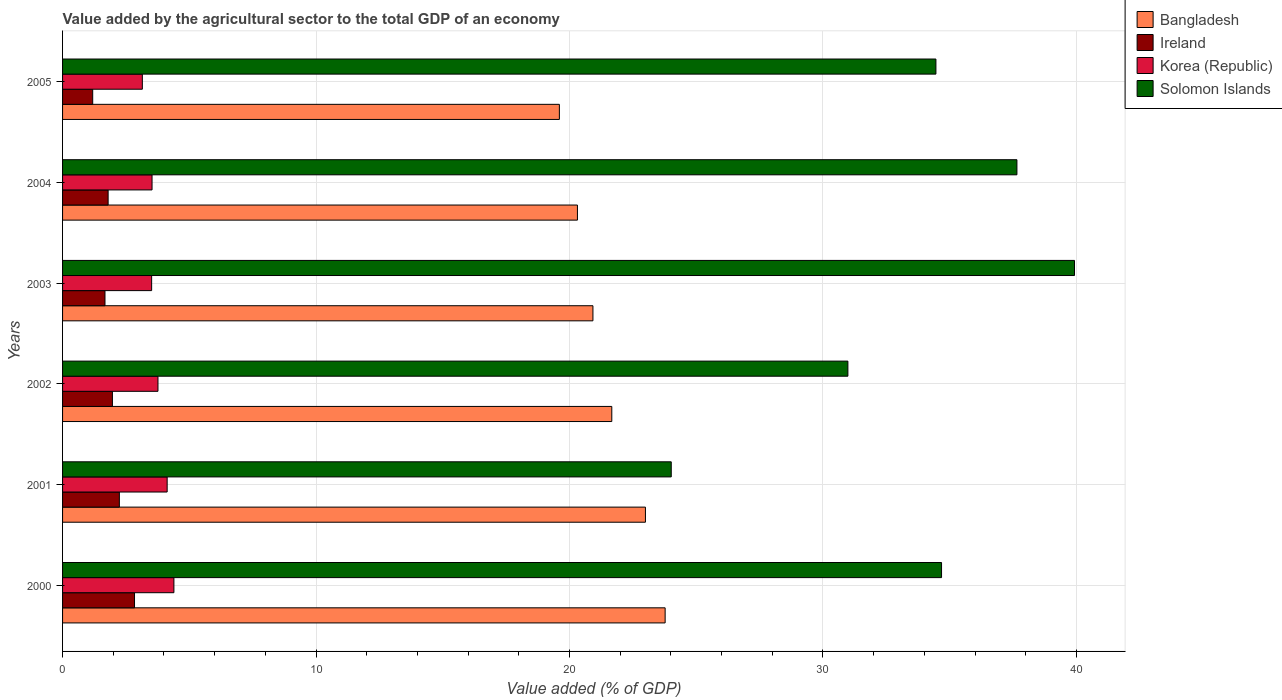How many different coloured bars are there?
Offer a very short reply. 4. Are the number of bars per tick equal to the number of legend labels?
Your answer should be very brief. Yes. How many bars are there on the 5th tick from the bottom?
Ensure brevity in your answer.  4. What is the label of the 3rd group of bars from the top?
Your answer should be compact. 2003. In how many cases, is the number of bars for a given year not equal to the number of legend labels?
Your answer should be very brief. 0. What is the value added by the agricultural sector to the total GDP in Solomon Islands in 2005?
Provide a succinct answer. 34.46. Across all years, what is the maximum value added by the agricultural sector to the total GDP in Korea (Republic)?
Offer a terse response. 4.39. Across all years, what is the minimum value added by the agricultural sector to the total GDP in Bangladesh?
Provide a succinct answer. 19.6. In which year was the value added by the agricultural sector to the total GDP in Solomon Islands minimum?
Keep it short and to the point. 2001. What is the total value added by the agricultural sector to the total GDP in Ireland in the graph?
Provide a succinct answer. 11.71. What is the difference between the value added by the agricultural sector to the total GDP in Korea (Republic) in 2000 and that in 2003?
Make the answer very short. 0.88. What is the difference between the value added by the agricultural sector to the total GDP in Solomon Islands in 2004 and the value added by the agricultural sector to the total GDP in Bangladesh in 2002?
Keep it short and to the point. 15.98. What is the average value added by the agricultural sector to the total GDP in Bangladesh per year?
Offer a terse response. 21.55. In the year 2003, what is the difference between the value added by the agricultural sector to the total GDP in Korea (Republic) and value added by the agricultural sector to the total GDP in Bangladesh?
Give a very brief answer. -17.41. What is the ratio of the value added by the agricultural sector to the total GDP in Korea (Republic) in 2000 to that in 2001?
Offer a very short reply. 1.06. Is the difference between the value added by the agricultural sector to the total GDP in Korea (Republic) in 2000 and 2004 greater than the difference between the value added by the agricultural sector to the total GDP in Bangladesh in 2000 and 2004?
Your answer should be compact. No. What is the difference between the highest and the second highest value added by the agricultural sector to the total GDP in Korea (Republic)?
Give a very brief answer. 0.27. What is the difference between the highest and the lowest value added by the agricultural sector to the total GDP in Ireland?
Provide a succinct answer. 1.65. In how many years, is the value added by the agricultural sector to the total GDP in Solomon Islands greater than the average value added by the agricultural sector to the total GDP in Solomon Islands taken over all years?
Ensure brevity in your answer.  4. Is the sum of the value added by the agricultural sector to the total GDP in Solomon Islands in 2000 and 2005 greater than the maximum value added by the agricultural sector to the total GDP in Korea (Republic) across all years?
Keep it short and to the point. Yes. Is it the case that in every year, the sum of the value added by the agricultural sector to the total GDP in Korea (Republic) and value added by the agricultural sector to the total GDP in Solomon Islands is greater than the sum of value added by the agricultural sector to the total GDP in Ireland and value added by the agricultural sector to the total GDP in Bangladesh?
Offer a very short reply. No. What does the 2nd bar from the bottom in 2001 represents?
Your answer should be very brief. Ireland. How many bars are there?
Offer a terse response. 24. What is the difference between two consecutive major ticks on the X-axis?
Your response must be concise. 10. Does the graph contain any zero values?
Your answer should be very brief. No. Does the graph contain grids?
Offer a very short reply. Yes. How many legend labels are there?
Offer a terse response. 4. What is the title of the graph?
Offer a terse response. Value added by the agricultural sector to the total GDP of an economy. What is the label or title of the X-axis?
Make the answer very short. Value added (% of GDP). What is the Value added (% of GDP) of Bangladesh in 2000?
Make the answer very short. 23.77. What is the Value added (% of GDP) of Ireland in 2000?
Your response must be concise. 2.84. What is the Value added (% of GDP) in Korea (Republic) in 2000?
Make the answer very short. 4.39. What is the Value added (% of GDP) of Solomon Islands in 2000?
Your response must be concise. 34.68. What is the Value added (% of GDP) in Bangladesh in 2001?
Your response must be concise. 23. What is the Value added (% of GDP) in Ireland in 2001?
Your answer should be compact. 2.24. What is the Value added (% of GDP) in Korea (Republic) in 2001?
Give a very brief answer. 4.13. What is the Value added (% of GDP) in Solomon Islands in 2001?
Offer a terse response. 24.01. What is the Value added (% of GDP) in Bangladesh in 2002?
Provide a short and direct response. 21.67. What is the Value added (% of GDP) in Ireland in 2002?
Offer a terse response. 1.97. What is the Value added (% of GDP) in Korea (Republic) in 2002?
Keep it short and to the point. 3.76. What is the Value added (% of GDP) in Solomon Islands in 2002?
Make the answer very short. 30.98. What is the Value added (% of GDP) in Bangladesh in 2003?
Provide a short and direct response. 20.92. What is the Value added (% of GDP) in Ireland in 2003?
Offer a terse response. 1.67. What is the Value added (% of GDP) of Korea (Republic) in 2003?
Ensure brevity in your answer.  3.51. What is the Value added (% of GDP) in Solomon Islands in 2003?
Your answer should be compact. 39.92. What is the Value added (% of GDP) of Bangladesh in 2004?
Provide a succinct answer. 20.31. What is the Value added (% of GDP) in Ireland in 2004?
Your answer should be compact. 1.8. What is the Value added (% of GDP) of Korea (Republic) in 2004?
Keep it short and to the point. 3.53. What is the Value added (% of GDP) of Solomon Islands in 2004?
Make the answer very short. 37.65. What is the Value added (% of GDP) of Bangladesh in 2005?
Provide a succinct answer. 19.6. What is the Value added (% of GDP) in Ireland in 2005?
Make the answer very short. 1.19. What is the Value added (% of GDP) of Korea (Republic) in 2005?
Ensure brevity in your answer.  3.15. What is the Value added (% of GDP) in Solomon Islands in 2005?
Your answer should be very brief. 34.46. Across all years, what is the maximum Value added (% of GDP) of Bangladesh?
Ensure brevity in your answer.  23.77. Across all years, what is the maximum Value added (% of GDP) of Ireland?
Your response must be concise. 2.84. Across all years, what is the maximum Value added (% of GDP) of Korea (Republic)?
Make the answer very short. 4.39. Across all years, what is the maximum Value added (% of GDP) in Solomon Islands?
Provide a short and direct response. 39.92. Across all years, what is the minimum Value added (% of GDP) in Bangladesh?
Give a very brief answer. 19.6. Across all years, what is the minimum Value added (% of GDP) in Ireland?
Offer a very short reply. 1.19. Across all years, what is the minimum Value added (% of GDP) of Korea (Republic)?
Offer a terse response. 3.15. Across all years, what is the minimum Value added (% of GDP) of Solomon Islands?
Your answer should be compact. 24.01. What is the total Value added (% of GDP) of Bangladesh in the graph?
Make the answer very short. 129.27. What is the total Value added (% of GDP) in Ireland in the graph?
Offer a very short reply. 11.71. What is the total Value added (% of GDP) in Korea (Republic) in the graph?
Keep it short and to the point. 22.47. What is the total Value added (% of GDP) in Solomon Islands in the graph?
Offer a very short reply. 201.7. What is the difference between the Value added (% of GDP) of Bangladesh in 2000 and that in 2001?
Ensure brevity in your answer.  0.78. What is the difference between the Value added (% of GDP) in Ireland in 2000 and that in 2001?
Give a very brief answer. 0.6. What is the difference between the Value added (% of GDP) in Korea (Republic) in 2000 and that in 2001?
Ensure brevity in your answer.  0.27. What is the difference between the Value added (% of GDP) of Solomon Islands in 2000 and that in 2001?
Offer a very short reply. 10.66. What is the difference between the Value added (% of GDP) of Bangladesh in 2000 and that in 2002?
Your answer should be compact. 2.1. What is the difference between the Value added (% of GDP) in Ireland in 2000 and that in 2002?
Provide a succinct answer. 0.87. What is the difference between the Value added (% of GDP) in Korea (Republic) in 2000 and that in 2002?
Your answer should be very brief. 0.63. What is the difference between the Value added (% of GDP) of Solomon Islands in 2000 and that in 2002?
Your response must be concise. 3.7. What is the difference between the Value added (% of GDP) in Bangladesh in 2000 and that in 2003?
Provide a short and direct response. 2.85. What is the difference between the Value added (% of GDP) in Ireland in 2000 and that in 2003?
Your answer should be compact. 1.17. What is the difference between the Value added (% of GDP) of Korea (Republic) in 2000 and that in 2003?
Offer a very short reply. 0.88. What is the difference between the Value added (% of GDP) of Solomon Islands in 2000 and that in 2003?
Provide a short and direct response. -5.25. What is the difference between the Value added (% of GDP) in Bangladesh in 2000 and that in 2004?
Make the answer very short. 3.46. What is the difference between the Value added (% of GDP) of Ireland in 2000 and that in 2004?
Ensure brevity in your answer.  1.04. What is the difference between the Value added (% of GDP) in Korea (Republic) in 2000 and that in 2004?
Ensure brevity in your answer.  0.86. What is the difference between the Value added (% of GDP) in Solomon Islands in 2000 and that in 2004?
Your response must be concise. -2.97. What is the difference between the Value added (% of GDP) in Bangladesh in 2000 and that in 2005?
Your answer should be very brief. 4.17. What is the difference between the Value added (% of GDP) of Ireland in 2000 and that in 2005?
Ensure brevity in your answer.  1.65. What is the difference between the Value added (% of GDP) in Korea (Republic) in 2000 and that in 2005?
Keep it short and to the point. 1.25. What is the difference between the Value added (% of GDP) in Solomon Islands in 2000 and that in 2005?
Make the answer very short. 0.22. What is the difference between the Value added (% of GDP) of Bangladesh in 2001 and that in 2002?
Your answer should be compact. 1.33. What is the difference between the Value added (% of GDP) of Ireland in 2001 and that in 2002?
Give a very brief answer. 0.27. What is the difference between the Value added (% of GDP) of Korea (Republic) in 2001 and that in 2002?
Your response must be concise. 0.36. What is the difference between the Value added (% of GDP) in Solomon Islands in 2001 and that in 2002?
Make the answer very short. -6.97. What is the difference between the Value added (% of GDP) of Bangladesh in 2001 and that in 2003?
Keep it short and to the point. 2.07. What is the difference between the Value added (% of GDP) of Ireland in 2001 and that in 2003?
Your answer should be very brief. 0.57. What is the difference between the Value added (% of GDP) in Korea (Republic) in 2001 and that in 2003?
Your answer should be very brief. 0.61. What is the difference between the Value added (% of GDP) of Solomon Islands in 2001 and that in 2003?
Keep it short and to the point. -15.91. What is the difference between the Value added (% of GDP) in Bangladesh in 2001 and that in 2004?
Ensure brevity in your answer.  2.68. What is the difference between the Value added (% of GDP) in Ireland in 2001 and that in 2004?
Your response must be concise. 0.44. What is the difference between the Value added (% of GDP) in Korea (Republic) in 2001 and that in 2004?
Your answer should be compact. 0.6. What is the difference between the Value added (% of GDP) in Solomon Islands in 2001 and that in 2004?
Give a very brief answer. -13.64. What is the difference between the Value added (% of GDP) in Bangladesh in 2001 and that in 2005?
Offer a very short reply. 3.4. What is the difference between the Value added (% of GDP) in Ireland in 2001 and that in 2005?
Provide a short and direct response. 1.05. What is the difference between the Value added (% of GDP) in Korea (Republic) in 2001 and that in 2005?
Keep it short and to the point. 0.98. What is the difference between the Value added (% of GDP) in Solomon Islands in 2001 and that in 2005?
Make the answer very short. -10.44. What is the difference between the Value added (% of GDP) of Bangladesh in 2002 and that in 2003?
Make the answer very short. 0.74. What is the difference between the Value added (% of GDP) of Ireland in 2002 and that in 2003?
Your answer should be very brief. 0.29. What is the difference between the Value added (% of GDP) in Korea (Republic) in 2002 and that in 2003?
Your response must be concise. 0.25. What is the difference between the Value added (% of GDP) in Solomon Islands in 2002 and that in 2003?
Offer a terse response. -8.94. What is the difference between the Value added (% of GDP) in Bangladesh in 2002 and that in 2004?
Provide a short and direct response. 1.36. What is the difference between the Value added (% of GDP) in Ireland in 2002 and that in 2004?
Your response must be concise. 0.17. What is the difference between the Value added (% of GDP) in Korea (Republic) in 2002 and that in 2004?
Give a very brief answer. 0.23. What is the difference between the Value added (% of GDP) of Solomon Islands in 2002 and that in 2004?
Provide a succinct answer. -6.67. What is the difference between the Value added (% of GDP) in Bangladesh in 2002 and that in 2005?
Your answer should be very brief. 2.07. What is the difference between the Value added (% of GDP) of Ireland in 2002 and that in 2005?
Ensure brevity in your answer.  0.78. What is the difference between the Value added (% of GDP) in Korea (Republic) in 2002 and that in 2005?
Provide a short and direct response. 0.62. What is the difference between the Value added (% of GDP) in Solomon Islands in 2002 and that in 2005?
Your answer should be very brief. -3.47. What is the difference between the Value added (% of GDP) in Bangladesh in 2003 and that in 2004?
Your answer should be very brief. 0.61. What is the difference between the Value added (% of GDP) of Ireland in 2003 and that in 2004?
Keep it short and to the point. -0.12. What is the difference between the Value added (% of GDP) of Korea (Republic) in 2003 and that in 2004?
Keep it short and to the point. -0.02. What is the difference between the Value added (% of GDP) in Solomon Islands in 2003 and that in 2004?
Your answer should be compact. 2.27. What is the difference between the Value added (% of GDP) in Bangladesh in 2003 and that in 2005?
Offer a very short reply. 1.32. What is the difference between the Value added (% of GDP) of Ireland in 2003 and that in 2005?
Your answer should be compact. 0.48. What is the difference between the Value added (% of GDP) of Korea (Republic) in 2003 and that in 2005?
Keep it short and to the point. 0.37. What is the difference between the Value added (% of GDP) in Solomon Islands in 2003 and that in 2005?
Provide a short and direct response. 5.47. What is the difference between the Value added (% of GDP) of Bangladesh in 2004 and that in 2005?
Your answer should be compact. 0.71. What is the difference between the Value added (% of GDP) of Ireland in 2004 and that in 2005?
Offer a terse response. 0.61. What is the difference between the Value added (% of GDP) in Korea (Republic) in 2004 and that in 2005?
Keep it short and to the point. 0.38. What is the difference between the Value added (% of GDP) of Solomon Islands in 2004 and that in 2005?
Your answer should be very brief. 3.2. What is the difference between the Value added (% of GDP) in Bangladesh in 2000 and the Value added (% of GDP) in Ireland in 2001?
Offer a very short reply. 21.53. What is the difference between the Value added (% of GDP) in Bangladesh in 2000 and the Value added (% of GDP) in Korea (Republic) in 2001?
Your answer should be compact. 19.65. What is the difference between the Value added (% of GDP) of Bangladesh in 2000 and the Value added (% of GDP) of Solomon Islands in 2001?
Your response must be concise. -0.24. What is the difference between the Value added (% of GDP) of Ireland in 2000 and the Value added (% of GDP) of Korea (Republic) in 2001?
Your response must be concise. -1.29. What is the difference between the Value added (% of GDP) in Ireland in 2000 and the Value added (% of GDP) in Solomon Islands in 2001?
Give a very brief answer. -21.18. What is the difference between the Value added (% of GDP) of Korea (Republic) in 2000 and the Value added (% of GDP) of Solomon Islands in 2001?
Offer a very short reply. -19.62. What is the difference between the Value added (% of GDP) of Bangladesh in 2000 and the Value added (% of GDP) of Ireland in 2002?
Provide a short and direct response. 21.81. What is the difference between the Value added (% of GDP) in Bangladesh in 2000 and the Value added (% of GDP) in Korea (Republic) in 2002?
Offer a very short reply. 20.01. What is the difference between the Value added (% of GDP) of Bangladesh in 2000 and the Value added (% of GDP) of Solomon Islands in 2002?
Make the answer very short. -7.21. What is the difference between the Value added (% of GDP) of Ireland in 2000 and the Value added (% of GDP) of Korea (Republic) in 2002?
Offer a terse response. -0.92. What is the difference between the Value added (% of GDP) in Ireland in 2000 and the Value added (% of GDP) in Solomon Islands in 2002?
Make the answer very short. -28.14. What is the difference between the Value added (% of GDP) in Korea (Republic) in 2000 and the Value added (% of GDP) in Solomon Islands in 2002?
Give a very brief answer. -26.59. What is the difference between the Value added (% of GDP) in Bangladesh in 2000 and the Value added (% of GDP) in Ireland in 2003?
Ensure brevity in your answer.  22.1. What is the difference between the Value added (% of GDP) in Bangladesh in 2000 and the Value added (% of GDP) in Korea (Republic) in 2003?
Offer a terse response. 20.26. What is the difference between the Value added (% of GDP) of Bangladesh in 2000 and the Value added (% of GDP) of Solomon Islands in 2003?
Ensure brevity in your answer.  -16.15. What is the difference between the Value added (% of GDP) of Ireland in 2000 and the Value added (% of GDP) of Korea (Republic) in 2003?
Provide a succinct answer. -0.68. What is the difference between the Value added (% of GDP) of Ireland in 2000 and the Value added (% of GDP) of Solomon Islands in 2003?
Your response must be concise. -37.08. What is the difference between the Value added (% of GDP) of Korea (Republic) in 2000 and the Value added (% of GDP) of Solomon Islands in 2003?
Make the answer very short. -35.53. What is the difference between the Value added (% of GDP) of Bangladesh in 2000 and the Value added (% of GDP) of Ireland in 2004?
Ensure brevity in your answer.  21.98. What is the difference between the Value added (% of GDP) of Bangladesh in 2000 and the Value added (% of GDP) of Korea (Republic) in 2004?
Make the answer very short. 20.24. What is the difference between the Value added (% of GDP) of Bangladesh in 2000 and the Value added (% of GDP) of Solomon Islands in 2004?
Provide a short and direct response. -13.88. What is the difference between the Value added (% of GDP) of Ireland in 2000 and the Value added (% of GDP) of Korea (Republic) in 2004?
Make the answer very short. -0.69. What is the difference between the Value added (% of GDP) in Ireland in 2000 and the Value added (% of GDP) in Solomon Islands in 2004?
Provide a succinct answer. -34.81. What is the difference between the Value added (% of GDP) in Korea (Republic) in 2000 and the Value added (% of GDP) in Solomon Islands in 2004?
Give a very brief answer. -33.26. What is the difference between the Value added (% of GDP) of Bangladesh in 2000 and the Value added (% of GDP) of Ireland in 2005?
Offer a terse response. 22.58. What is the difference between the Value added (% of GDP) of Bangladesh in 2000 and the Value added (% of GDP) of Korea (Republic) in 2005?
Ensure brevity in your answer.  20.63. What is the difference between the Value added (% of GDP) of Bangladesh in 2000 and the Value added (% of GDP) of Solomon Islands in 2005?
Offer a terse response. -10.68. What is the difference between the Value added (% of GDP) of Ireland in 2000 and the Value added (% of GDP) of Korea (Republic) in 2005?
Your answer should be very brief. -0.31. What is the difference between the Value added (% of GDP) of Ireland in 2000 and the Value added (% of GDP) of Solomon Islands in 2005?
Provide a succinct answer. -31.62. What is the difference between the Value added (% of GDP) of Korea (Republic) in 2000 and the Value added (% of GDP) of Solomon Islands in 2005?
Ensure brevity in your answer.  -30.06. What is the difference between the Value added (% of GDP) in Bangladesh in 2001 and the Value added (% of GDP) in Ireland in 2002?
Offer a very short reply. 21.03. What is the difference between the Value added (% of GDP) of Bangladesh in 2001 and the Value added (% of GDP) of Korea (Republic) in 2002?
Offer a very short reply. 19.23. What is the difference between the Value added (% of GDP) of Bangladesh in 2001 and the Value added (% of GDP) of Solomon Islands in 2002?
Ensure brevity in your answer.  -7.99. What is the difference between the Value added (% of GDP) of Ireland in 2001 and the Value added (% of GDP) of Korea (Republic) in 2002?
Give a very brief answer. -1.52. What is the difference between the Value added (% of GDP) of Ireland in 2001 and the Value added (% of GDP) of Solomon Islands in 2002?
Make the answer very short. -28.74. What is the difference between the Value added (% of GDP) in Korea (Republic) in 2001 and the Value added (% of GDP) in Solomon Islands in 2002?
Provide a short and direct response. -26.86. What is the difference between the Value added (% of GDP) in Bangladesh in 2001 and the Value added (% of GDP) in Ireland in 2003?
Ensure brevity in your answer.  21.32. What is the difference between the Value added (% of GDP) of Bangladesh in 2001 and the Value added (% of GDP) of Korea (Republic) in 2003?
Provide a succinct answer. 19.48. What is the difference between the Value added (% of GDP) of Bangladesh in 2001 and the Value added (% of GDP) of Solomon Islands in 2003?
Offer a terse response. -16.93. What is the difference between the Value added (% of GDP) of Ireland in 2001 and the Value added (% of GDP) of Korea (Republic) in 2003?
Offer a very short reply. -1.27. What is the difference between the Value added (% of GDP) in Ireland in 2001 and the Value added (% of GDP) in Solomon Islands in 2003?
Your response must be concise. -37.68. What is the difference between the Value added (% of GDP) in Korea (Republic) in 2001 and the Value added (% of GDP) in Solomon Islands in 2003?
Offer a very short reply. -35.8. What is the difference between the Value added (% of GDP) in Bangladesh in 2001 and the Value added (% of GDP) in Ireland in 2004?
Your response must be concise. 21.2. What is the difference between the Value added (% of GDP) of Bangladesh in 2001 and the Value added (% of GDP) of Korea (Republic) in 2004?
Your answer should be very brief. 19.47. What is the difference between the Value added (% of GDP) of Bangladesh in 2001 and the Value added (% of GDP) of Solomon Islands in 2004?
Your response must be concise. -14.66. What is the difference between the Value added (% of GDP) of Ireland in 2001 and the Value added (% of GDP) of Korea (Republic) in 2004?
Provide a succinct answer. -1.29. What is the difference between the Value added (% of GDP) in Ireland in 2001 and the Value added (% of GDP) in Solomon Islands in 2004?
Your response must be concise. -35.41. What is the difference between the Value added (% of GDP) of Korea (Republic) in 2001 and the Value added (% of GDP) of Solomon Islands in 2004?
Your response must be concise. -33.53. What is the difference between the Value added (% of GDP) in Bangladesh in 2001 and the Value added (% of GDP) in Ireland in 2005?
Give a very brief answer. 21.81. What is the difference between the Value added (% of GDP) of Bangladesh in 2001 and the Value added (% of GDP) of Korea (Republic) in 2005?
Make the answer very short. 19.85. What is the difference between the Value added (% of GDP) in Bangladesh in 2001 and the Value added (% of GDP) in Solomon Islands in 2005?
Keep it short and to the point. -11.46. What is the difference between the Value added (% of GDP) in Ireland in 2001 and the Value added (% of GDP) in Korea (Republic) in 2005?
Provide a short and direct response. -0.91. What is the difference between the Value added (% of GDP) of Ireland in 2001 and the Value added (% of GDP) of Solomon Islands in 2005?
Ensure brevity in your answer.  -32.22. What is the difference between the Value added (% of GDP) of Korea (Republic) in 2001 and the Value added (% of GDP) of Solomon Islands in 2005?
Make the answer very short. -30.33. What is the difference between the Value added (% of GDP) in Bangladesh in 2002 and the Value added (% of GDP) in Ireland in 2003?
Provide a short and direct response. 20. What is the difference between the Value added (% of GDP) in Bangladesh in 2002 and the Value added (% of GDP) in Korea (Republic) in 2003?
Give a very brief answer. 18.15. What is the difference between the Value added (% of GDP) in Bangladesh in 2002 and the Value added (% of GDP) in Solomon Islands in 2003?
Provide a succinct answer. -18.25. What is the difference between the Value added (% of GDP) of Ireland in 2002 and the Value added (% of GDP) of Korea (Republic) in 2003?
Provide a succinct answer. -1.55. What is the difference between the Value added (% of GDP) of Ireland in 2002 and the Value added (% of GDP) of Solomon Islands in 2003?
Make the answer very short. -37.96. What is the difference between the Value added (% of GDP) in Korea (Republic) in 2002 and the Value added (% of GDP) in Solomon Islands in 2003?
Provide a succinct answer. -36.16. What is the difference between the Value added (% of GDP) of Bangladesh in 2002 and the Value added (% of GDP) of Ireland in 2004?
Your response must be concise. 19.87. What is the difference between the Value added (% of GDP) in Bangladesh in 2002 and the Value added (% of GDP) in Korea (Republic) in 2004?
Make the answer very short. 18.14. What is the difference between the Value added (% of GDP) in Bangladesh in 2002 and the Value added (% of GDP) in Solomon Islands in 2004?
Provide a succinct answer. -15.98. What is the difference between the Value added (% of GDP) of Ireland in 2002 and the Value added (% of GDP) of Korea (Republic) in 2004?
Ensure brevity in your answer.  -1.56. What is the difference between the Value added (% of GDP) in Ireland in 2002 and the Value added (% of GDP) in Solomon Islands in 2004?
Give a very brief answer. -35.68. What is the difference between the Value added (% of GDP) of Korea (Republic) in 2002 and the Value added (% of GDP) of Solomon Islands in 2004?
Your answer should be very brief. -33.89. What is the difference between the Value added (% of GDP) of Bangladesh in 2002 and the Value added (% of GDP) of Ireland in 2005?
Provide a succinct answer. 20.48. What is the difference between the Value added (% of GDP) of Bangladesh in 2002 and the Value added (% of GDP) of Korea (Republic) in 2005?
Offer a very short reply. 18.52. What is the difference between the Value added (% of GDP) of Bangladesh in 2002 and the Value added (% of GDP) of Solomon Islands in 2005?
Ensure brevity in your answer.  -12.79. What is the difference between the Value added (% of GDP) of Ireland in 2002 and the Value added (% of GDP) of Korea (Republic) in 2005?
Make the answer very short. -1.18. What is the difference between the Value added (% of GDP) in Ireland in 2002 and the Value added (% of GDP) in Solomon Islands in 2005?
Provide a short and direct response. -32.49. What is the difference between the Value added (% of GDP) of Korea (Republic) in 2002 and the Value added (% of GDP) of Solomon Islands in 2005?
Your response must be concise. -30.69. What is the difference between the Value added (% of GDP) of Bangladesh in 2003 and the Value added (% of GDP) of Ireland in 2004?
Provide a succinct answer. 19.13. What is the difference between the Value added (% of GDP) in Bangladesh in 2003 and the Value added (% of GDP) in Korea (Republic) in 2004?
Your answer should be very brief. 17.39. What is the difference between the Value added (% of GDP) of Bangladesh in 2003 and the Value added (% of GDP) of Solomon Islands in 2004?
Provide a succinct answer. -16.73. What is the difference between the Value added (% of GDP) in Ireland in 2003 and the Value added (% of GDP) in Korea (Republic) in 2004?
Give a very brief answer. -1.86. What is the difference between the Value added (% of GDP) in Ireland in 2003 and the Value added (% of GDP) in Solomon Islands in 2004?
Offer a terse response. -35.98. What is the difference between the Value added (% of GDP) in Korea (Republic) in 2003 and the Value added (% of GDP) in Solomon Islands in 2004?
Offer a terse response. -34.14. What is the difference between the Value added (% of GDP) in Bangladesh in 2003 and the Value added (% of GDP) in Ireland in 2005?
Give a very brief answer. 19.74. What is the difference between the Value added (% of GDP) of Bangladesh in 2003 and the Value added (% of GDP) of Korea (Republic) in 2005?
Your answer should be very brief. 17.78. What is the difference between the Value added (% of GDP) of Bangladesh in 2003 and the Value added (% of GDP) of Solomon Islands in 2005?
Provide a succinct answer. -13.53. What is the difference between the Value added (% of GDP) of Ireland in 2003 and the Value added (% of GDP) of Korea (Republic) in 2005?
Provide a short and direct response. -1.47. What is the difference between the Value added (% of GDP) in Ireland in 2003 and the Value added (% of GDP) in Solomon Islands in 2005?
Offer a very short reply. -32.78. What is the difference between the Value added (% of GDP) in Korea (Republic) in 2003 and the Value added (% of GDP) in Solomon Islands in 2005?
Your response must be concise. -30.94. What is the difference between the Value added (% of GDP) in Bangladesh in 2004 and the Value added (% of GDP) in Ireland in 2005?
Ensure brevity in your answer.  19.12. What is the difference between the Value added (% of GDP) in Bangladesh in 2004 and the Value added (% of GDP) in Korea (Republic) in 2005?
Keep it short and to the point. 17.17. What is the difference between the Value added (% of GDP) in Bangladesh in 2004 and the Value added (% of GDP) in Solomon Islands in 2005?
Offer a terse response. -14.14. What is the difference between the Value added (% of GDP) in Ireland in 2004 and the Value added (% of GDP) in Korea (Republic) in 2005?
Keep it short and to the point. -1.35. What is the difference between the Value added (% of GDP) of Ireland in 2004 and the Value added (% of GDP) of Solomon Islands in 2005?
Your response must be concise. -32.66. What is the difference between the Value added (% of GDP) in Korea (Republic) in 2004 and the Value added (% of GDP) in Solomon Islands in 2005?
Make the answer very short. -30.93. What is the average Value added (% of GDP) of Bangladesh per year?
Offer a very short reply. 21.55. What is the average Value added (% of GDP) in Ireland per year?
Provide a succinct answer. 1.95. What is the average Value added (% of GDP) in Korea (Republic) per year?
Your answer should be very brief. 3.75. What is the average Value added (% of GDP) of Solomon Islands per year?
Your answer should be very brief. 33.62. In the year 2000, what is the difference between the Value added (% of GDP) in Bangladesh and Value added (% of GDP) in Ireland?
Your answer should be compact. 20.93. In the year 2000, what is the difference between the Value added (% of GDP) in Bangladesh and Value added (% of GDP) in Korea (Republic)?
Keep it short and to the point. 19.38. In the year 2000, what is the difference between the Value added (% of GDP) of Bangladesh and Value added (% of GDP) of Solomon Islands?
Give a very brief answer. -10.91. In the year 2000, what is the difference between the Value added (% of GDP) of Ireland and Value added (% of GDP) of Korea (Republic)?
Ensure brevity in your answer.  -1.55. In the year 2000, what is the difference between the Value added (% of GDP) in Ireland and Value added (% of GDP) in Solomon Islands?
Your answer should be compact. -31.84. In the year 2000, what is the difference between the Value added (% of GDP) of Korea (Republic) and Value added (% of GDP) of Solomon Islands?
Provide a succinct answer. -30.28. In the year 2001, what is the difference between the Value added (% of GDP) in Bangladesh and Value added (% of GDP) in Ireland?
Offer a very short reply. 20.75. In the year 2001, what is the difference between the Value added (% of GDP) of Bangladesh and Value added (% of GDP) of Korea (Republic)?
Your answer should be compact. 18.87. In the year 2001, what is the difference between the Value added (% of GDP) of Bangladesh and Value added (% of GDP) of Solomon Islands?
Your response must be concise. -1.02. In the year 2001, what is the difference between the Value added (% of GDP) of Ireland and Value added (% of GDP) of Korea (Republic)?
Your response must be concise. -1.89. In the year 2001, what is the difference between the Value added (% of GDP) in Ireland and Value added (% of GDP) in Solomon Islands?
Provide a short and direct response. -21.77. In the year 2001, what is the difference between the Value added (% of GDP) in Korea (Republic) and Value added (% of GDP) in Solomon Islands?
Your answer should be very brief. -19.89. In the year 2002, what is the difference between the Value added (% of GDP) of Bangladesh and Value added (% of GDP) of Ireland?
Offer a very short reply. 19.7. In the year 2002, what is the difference between the Value added (% of GDP) in Bangladesh and Value added (% of GDP) in Korea (Republic)?
Your answer should be very brief. 17.9. In the year 2002, what is the difference between the Value added (% of GDP) in Bangladesh and Value added (% of GDP) in Solomon Islands?
Provide a short and direct response. -9.31. In the year 2002, what is the difference between the Value added (% of GDP) in Ireland and Value added (% of GDP) in Korea (Republic)?
Offer a terse response. -1.8. In the year 2002, what is the difference between the Value added (% of GDP) of Ireland and Value added (% of GDP) of Solomon Islands?
Your answer should be compact. -29.02. In the year 2002, what is the difference between the Value added (% of GDP) in Korea (Republic) and Value added (% of GDP) in Solomon Islands?
Give a very brief answer. -27.22. In the year 2003, what is the difference between the Value added (% of GDP) of Bangladesh and Value added (% of GDP) of Ireland?
Provide a short and direct response. 19.25. In the year 2003, what is the difference between the Value added (% of GDP) of Bangladesh and Value added (% of GDP) of Korea (Republic)?
Provide a short and direct response. 17.41. In the year 2003, what is the difference between the Value added (% of GDP) in Bangladesh and Value added (% of GDP) in Solomon Islands?
Offer a terse response. -19. In the year 2003, what is the difference between the Value added (% of GDP) of Ireland and Value added (% of GDP) of Korea (Republic)?
Provide a succinct answer. -1.84. In the year 2003, what is the difference between the Value added (% of GDP) of Ireland and Value added (% of GDP) of Solomon Islands?
Provide a short and direct response. -38.25. In the year 2003, what is the difference between the Value added (% of GDP) in Korea (Republic) and Value added (% of GDP) in Solomon Islands?
Your answer should be compact. -36.41. In the year 2004, what is the difference between the Value added (% of GDP) of Bangladesh and Value added (% of GDP) of Ireland?
Offer a very short reply. 18.52. In the year 2004, what is the difference between the Value added (% of GDP) of Bangladesh and Value added (% of GDP) of Korea (Republic)?
Your response must be concise. 16.78. In the year 2004, what is the difference between the Value added (% of GDP) of Bangladesh and Value added (% of GDP) of Solomon Islands?
Offer a terse response. -17.34. In the year 2004, what is the difference between the Value added (% of GDP) in Ireland and Value added (% of GDP) in Korea (Republic)?
Provide a succinct answer. -1.73. In the year 2004, what is the difference between the Value added (% of GDP) in Ireland and Value added (% of GDP) in Solomon Islands?
Ensure brevity in your answer.  -35.85. In the year 2004, what is the difference between the Value added (% of GDP) in Korea (Republic) and Value added (% of GDP) in Solomon Islands?
Keep it short and to the point. -34.12. In the year 2005, what is the difference between the Value added (% of GDP) of Bangladesh and Value added (% of GDP) of Ireland?
Provide a short and direct response. 18.41. In the year 2005, what is the difference between the Value added (% of GDP) in Bangladesh and Value added (% of GDP) in Korea (Republic)?
Your answer should be very brief. 16.45. In the year 2005, what is the difference between the Value added (% of GDP) of Bangladesh and Value added (% of GDP) of Solomon Islands?
Ensure brevity in your answer.  -14.86. In the year 2005, what is the difference between the Value added (% of GDP) of Ireland and Value added (% of GDP) of Korea (Republic)?
Make the answer very short. -1.96. In the year 2005, what is the difference between the Value added (% of GDP) in Ireland and Value added (% of GDP) in Solomon Islands?
Keep it short and to the point. -33.27. In the year 2005, what is the difference between the Value added (% of GDP) in Korea (Republic) and Value added (% of GDP) in Solomon Islands?
Give a very brief answer. -31.31. What is the ratio of the Value added (% of GDP) in Bangladesh in 2000 to that in 2001?
Your response must be concise. 1.03. What is the ratio of the Value added (% of GDP) in Ireland in 2000 to that in 2001?
Keep it short and to the point. 1.27. What is the ratio of the Value added (% of GDP) in Korea (Republic) in 2000 to that in 2001?
Offer a terse response. 1.06. What is the ratio of the Value added (% of GDP) of Solomon Islands in 2000 to that in 2001?
Give a very brief answer. 1.44. What is the ratio of the Value added (% of GDP) of Bangladesh in 2000 to that in 2002?
Your answer should be compact. 1.1. What is the ratio of the Value added (% of GDP) of Ireland in 2000 to that in 2002?
Make the answer very short. 1.44. What is the ratio of the Value added (% of GDP) of Korea (Republic) in 2000 to that in 2002?
Give a very brief answer. 1.17. What is the ratio of the Value added (% of GDP) in Solomon Islands in 2000 to that in 2002?
Give a very brief answer. 1.12. What is the ratio of the Value added (% of GDP) in Bangladesh in 2000 to that in 2003?
Offer a very short reply. 1.14. What is the ratio of the Value added (% of GDP) of Ireland in 2000 to that in 2003?
Ensure brevity in your answer.  1.7. What is the ratio of the Value added (% of GDP) in Korea (Republic) in 2000 to that in 2003?
Offer a very short reply. 1.25. What is the ratio of the Value added (% of GDP) in Solomon Islands in 2000 to that in 2003?
Offer a very short reply. 0.87. What is the ratio of the Value added (% of GDP) in Bangladesh in 2000 to that in 2004?
Provide a succinct answer. 1.17. What is the ratio of the Value added (% of GDP) in Ireland in 2000 to that in 2004?
Give a very brief answer. 1.58. What is the ratio of the Value added (% of GDP) in Korea (Republic) in 2000 to that in 2004?
Give a very brief answer. 1.24. What is the ratio of the Value added (% of GDP) in Solomon Islands in 2000 to that in 2004?
Provide a short and direct response. 0.92. What is the ratio of the Value added (% of GDP) of Bangladesh in 2000 to that in 2005?
Your answer should be compact. 1.21. What is the ratio of the Value added (% of GDP) in Ireland in 2000 to that in 2005?
Offer a terse response. 2.39. What is the ratio of the Value added (% of GDP) in Korea (Republic) in 2000 to that in 2005?
Your answer should be compact. 1.4. What is the ratio of the Value added (% of GDP) in Solomon Islands in 2000 to that in 2005?
Offer a very short reply. 1.01. What is the ratio of the Value added (% of GDP) of Bangladesh in 2001 to that in 2002?
Your answer should be very brief. 1.06. What is the ratio of the Value added (% of GDP) of Ireland in 2001 to that in 2002?
Make the answer very short. 1.14. What is the ratio of the Value added (% of GDP) in Korea (Republic) in 2001 to that in 2002?
Provide a short and direct response. 1.1. What is the ratio of the Value added (% of GDP) of Solomon Islands in 2001 to that in 2002?
Make the answer very short. 0.78. What is the ratio of the Value added (% of GDP) of Bangladesh in 2001 to that in 2003?
Provide a succinct answer. 1.1. What is the ratio of the Value added (% of GDP) in Ireland in 2001 to that in 2003?
Give a very brief answer. 1.34. What is the ratio of the Value added (% of GDP) in Korea (Republic) in 2001 to that in 2003?
Make the answer very short. 1.17. What is the ratio of the Value added (% of GDP) of Solomon Islands in 2001 to that in 2003?
Ensure brevity in your answer.  0.6. What is the ratio of the Value added (% of GDP) in Bangladesh in 2001 to that in 2004?
Ensure brevity in your answer.  1.13. What is the ratio of the Value added (% of GDP) of Ireland in 2001 to that in 2004?
Keep it short and to the point. 1.25. What is the ratio of the Value added (% of GDP) in Korea (Republic) in 2001 to that in 2004?
Make the answer very short. 1.17. What is the ratio of the Value added (% of GDP) of Solomon Islands in 2001 to that in 2004?
Offer a terse response. 0.64. What is the ratio of the Value added (% of GDP) in Bangladesh in 2001 to that in 2005?
Your response must be concise. 1.17. What is the ratio of the Value added (% of GDP) of Ireland in 2001 to that in 2005?
Your answer should be very brief. 1.88. What is the ratio of the Value added (% of GDP) of Korea (Republic) in 2001 to that in 2005?
Make the answer very short. 1.31. What is the ratio of the Value added (% of GDP) of Solomon Islands in 2001 to that in 2005?
Offer a terse response. 0.7. What is the ratio of the Value added (% of GDP) of Bangladesh in 2002 to that in 2003?
Ensure brevity in your answer.  1.04. What is the ratio of the Value added (% of GDP) in Ireland in 2002 to that in 2003?
Your answer should be very brief. 1.18. What is the ratio of the Value added (% of GDP) in Korea (Republic) in 2002 to that in 2003?
Ensure brevity in your answer.  1.07. What is the ratio of the Value added (% of GDP) in Solomon Islands in 2002 to that in 2003?
Provide a short and direct response. 0.78. What is the ratio of the Value added (% of GDP) of Bangladesh in 2002 to that in 2004?
Your response must be concise. 1.07. What is the ratio of the Value added (% of GDP) in Ireland in 2002 to that in 2004?
Ensure brevity in your answer.  1.09. What is the ratio of the Value added (% of GDP) of Korea (Republic) in 2002 to that in 2004?
Offer a terse response. 1.07. What is the ratio of the Value added (% of GDP) of Solomon Islands in 2002 to that in 2004?
Keep it short and to the point. 0.82. What is the ratio of the Value added (% of GDP) in Bangladesh in 2002 to that in 2005?
Give a very brief answer. 1.11. What is the ratio of the Value added (% of GDP) in Ireland in 2002 to that in 2005?
Your answer should be compact. 1.65. What is the ratio of the Value added (% of GDP) of Korea (Republic) in 2002 to that in 2005?
Provide a short and direct response. 1.2. What is the ratio of the Value added (% of GDP) in Solomon Islands in 2002 to that in 2005?
Your answer should be very brief. 0.9. What is the ratio of the Value added (% of GDP) in Bangladesh in 2003 to that in 2004?
Ensure brevity in your answer.  1.03. What is the ratio of the Value added (% of GDP) of Solomon Islands in 2003 to that in 2004?
Provide a succinct answer. 1.06. What is the ratio of the Value added (% of GDP) of Bangladesh in 2003 to that in 2005?
Provide a succinct answer. 1.07. What is the ratio of the Value added (% of GDP) of Ireland in 2003 to that in 2005?
Ensure brevity in your answer.  1.41. What is the ratio of the Value added (% of GDP) of Korea (Republic) in 2003 to that in 2005?
Provide a short and direct response. 1.12. What is the ratio of the Value added (% of GDP) of Solomon Islands in 2003 to that in 2005?
Give a very brief answer. 1.16. What is the ratio of the Value added (% of GDP) of Bangladesh in 2004 to that in 2005?
Offer a very short reply. 1.04. What is the ratio of the Value added (% of GDP) of Ireland in 2004 to that in 2005?
Provide a short and direct response. 1.51. What is the ratio of the Value added (% of GDP) of Korea (Republic) in 2004 to that in 2005?
Ensure brevity in your answer.  1.12. What is the ratio of the Value added (% of GDP) of Solomon Islands in 2004 to that in 2005?
Provide a succinct answer. 1.09. What is the difference between the highest and the second highest Value added (% of GDP) of Bangladesh?
Keep it short and to the point. 0.78. What is the difference between the highest and the second highest Value added (% of GDP) in Ireland?
Your answer should be compact. 0.6. What is the difference between the highest and the second highest Value added (% of GDP) in Korea (Republic)?
Give a very brief answer. 0.27. What is the difference between the highest and the second highest Value added (% of GDP) of Solomon Islands?
Ensure brevity in your answer.  2.27. What is the difference between the highest and the lowest Value added (% of GDP) in Bangladesh?
Make the answer very short. 4.17. What is the difference between the highest and the lowest Value added (% of GDP) in Ireland?
Make the answer very short. 1.65. What is the difference between the highest and the lowest Value added (% of GDP) in Korea (Republic)?
Offer a terse response. 1.25. What is the difference between the highest and the lowest Value added (% of GDP) in Solomon Islands?
Your answer should be compact. 15.91. 